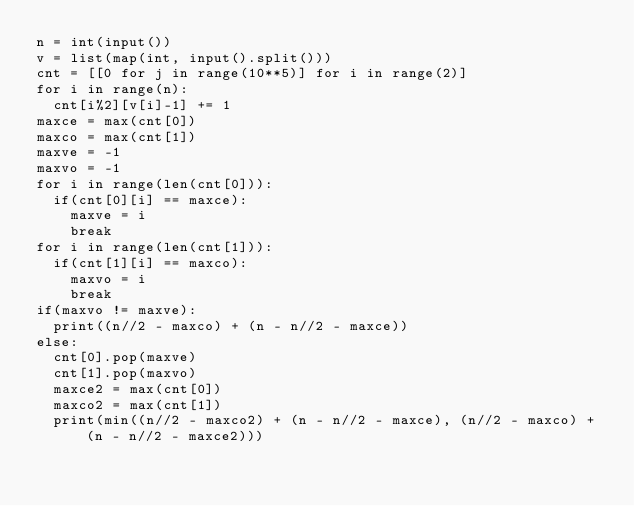Convert code to text. <code><loc_0><loc_0><loc_500><loc_500><_Python_>n = int(input())
v = list(map(int, input().split()))
cnt = [[0 for j in range(10**5)] for i in range(2)]
for i in range(n):
  cnt[i%2][v[i]-1] += 1
maxce = max(cnt[0])
maxco = max(cnt[1])
maxve = -1
maxvo = -1
for i in range(len(cnt[0])):
  if(cnt[0][i] == maxce):
    maxve = i
    break
for i in range(len(cnt[1])):
  if(cnt[1][i] == maxco):
    maxvo = i
    break
if(maxvo != maxve):
  print((n//2 - maxco) + (n - n//2 - maxce))
else:
  cnt[0].pop(maxve)
  cnt[1].pop(maxvo)
  maxce2 = max(cnt[0])
  maxco2 = max(cnt[1])
  print(min((n//2 - maxco2) + (n - n//2 - maxce), (n//2 - maxco) + (n - n//2 - maxce2)))</code> 